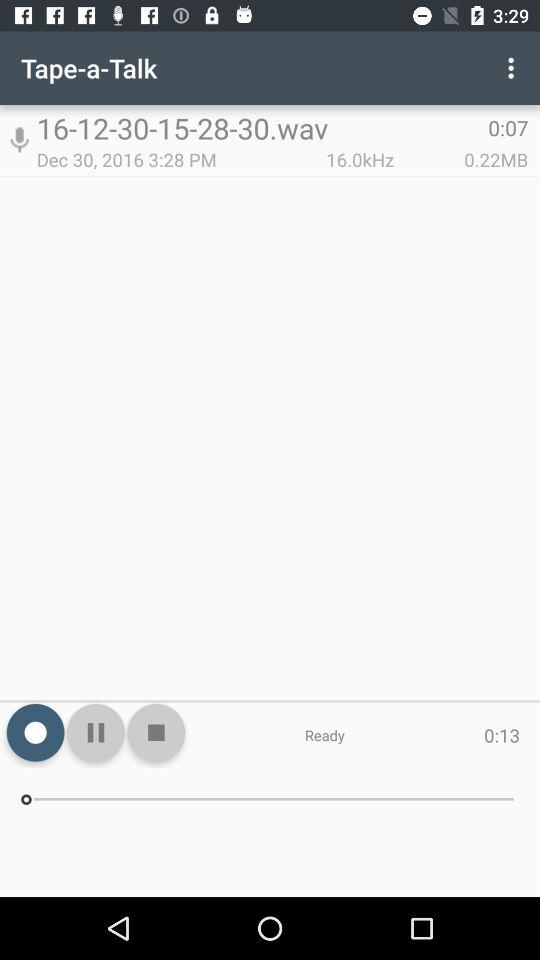How long has the audio been playing?
When the provided information is insufficient, respond with <no answer>. <no answer> 